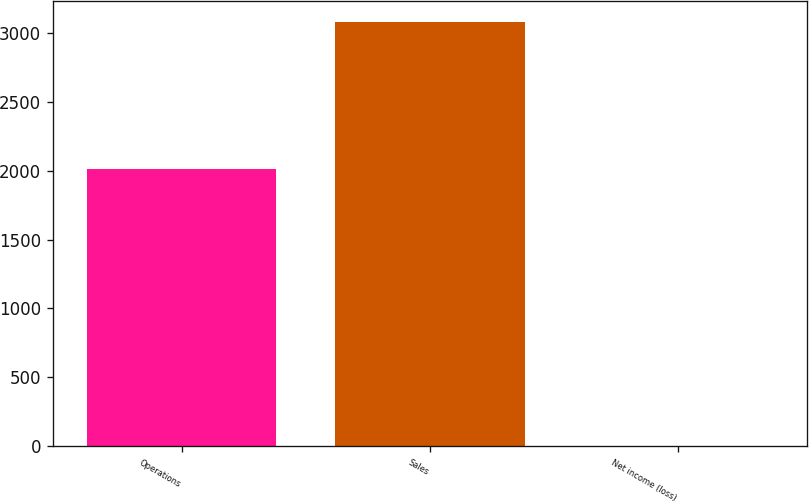<chart> <loc_0><loc_0><loc_500><loc_500><bar_chart><fcel>Operations<fcel>Sales<fcel>Net income (loss)<nl><fcel>2014<fcel>3082<fcel>1<nl></chart> 